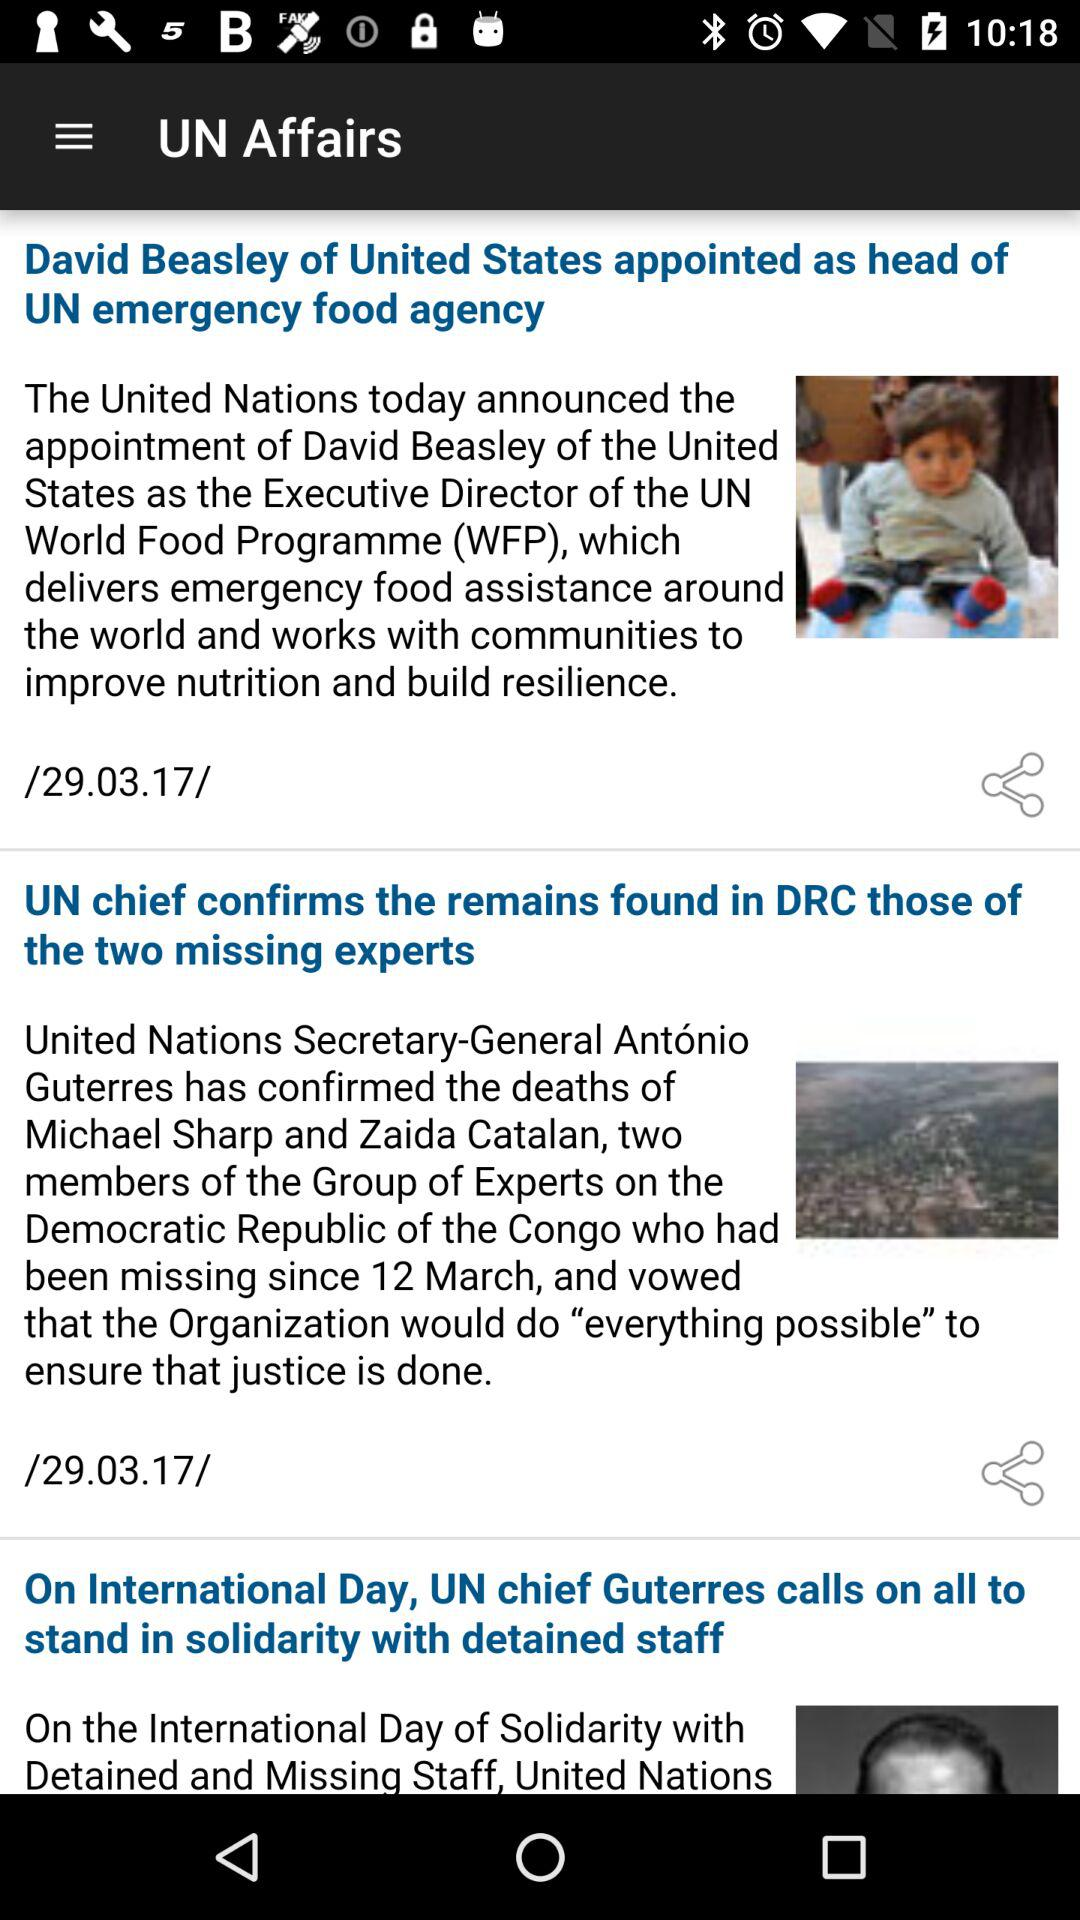What's the date of the news "UN chief confirms the remains found in DRC those of the two missing experts"? The date of the news is 29.03.17. 